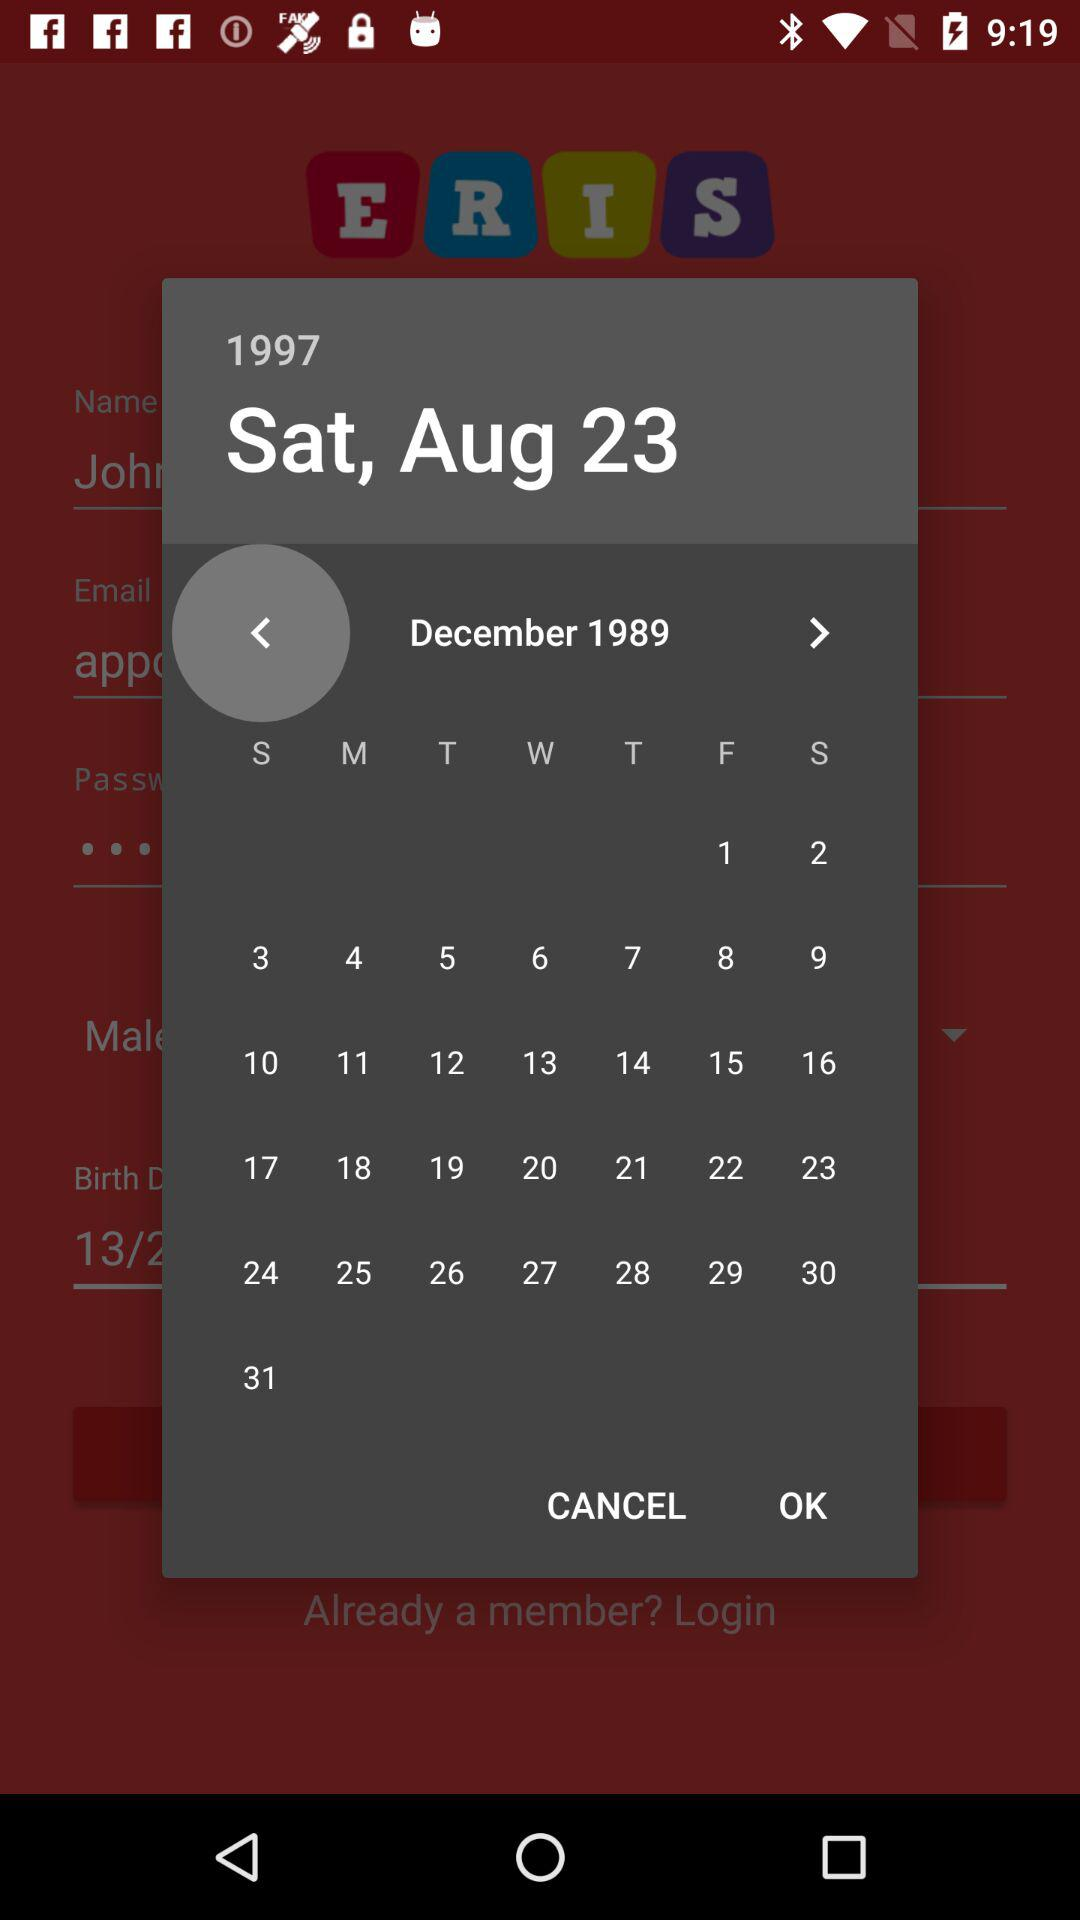What is the email address?
When the provided information is insufficient, respond with <no answer>. <no answer> 